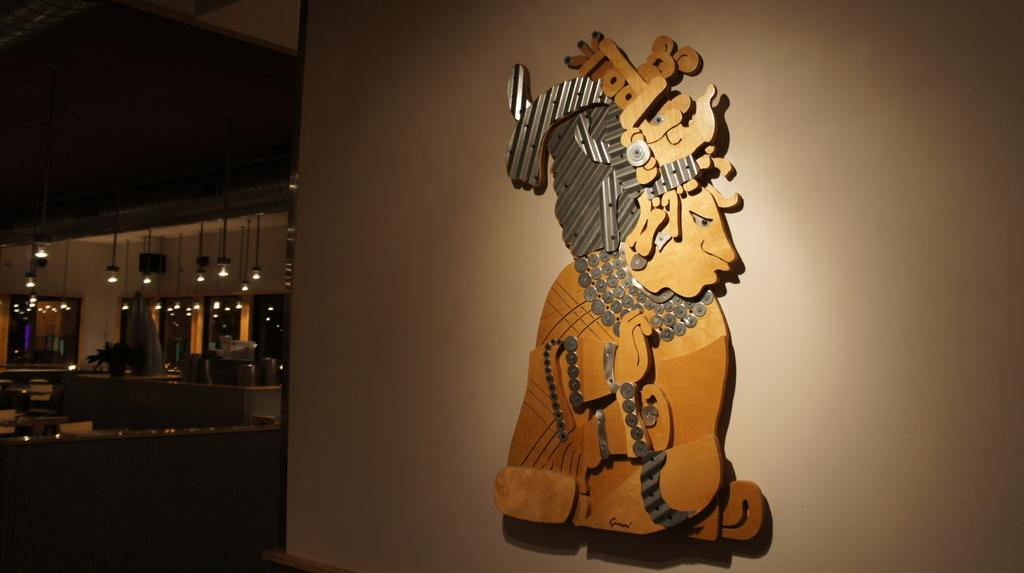What is attached to the wall in the image? There is an object attached to the wall in the image. What type of furniture is present in the image? There are chairs in the image. What can be used for illumination in the image? There are lights in the image. What can be seen in the left corner of the image? There are other objects in the left corner of the image. What color of paint is visible on the grass in the image? There is no grass present in the image, and therefore no paint on it. What type of front is depicted in the image? The image does not show a front, so it cannot be determined what type of front is depicted. 